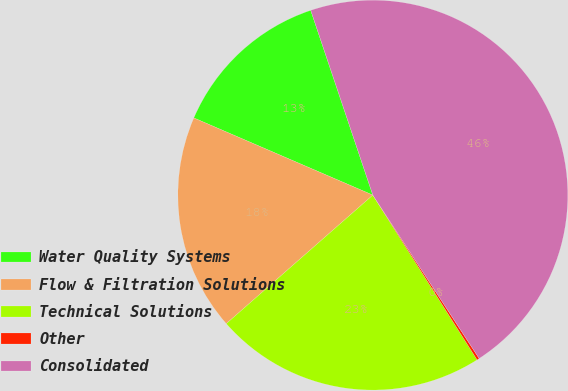<chart> <loc_0><loc_0><loc_500><loc_500><pie_chart><fcel>Water Quality Systems<fcel>Flow & Filtration Solutions<fcel>Technical Solutions<fcel>Other<fcel>Consolidated<nl><fcel>13.36%<fcel>17.94%<fcel>22.52%<fcel>0.2%<fcel>45.98%<nl></chart> 